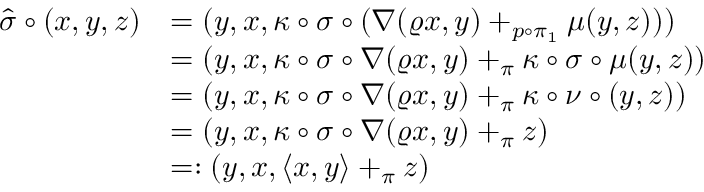<formula> <loc_0><loc_0><loc_500><loc_500>\begin{array} { r l } { \widehat { \sigma } \circ ( x , y , z ) } & { = ( y , x , \kappa \circ \sigma \circ ( \nabla ( \varrho x , y ) + _ { p \circ \pi _ { 1 } } \mu ( y , z ) ) ) } \\ & { = ( y , x , \kappa \circ \sigma \circ \nabla ( \varrho x , y ) + _ { \pi } \kappa \circ \sigma \circ \mu ( y , z ) ) } \\ & { = ( y , x , \kappa \circ \sigma \circ \nabla ( \varrho x , y ) + _ { \pi } \kappa \circ \nu \circ ( y , z ) ) } \\ & { = ( y , x , \kappa \circ \sigma \circ \nabla ( \varrho x , y ) + _ { \pi } z ) } \\ & { = \colon ( y , x , \langle x , y \rangle + _ { \pi } z ) } \end{array}</formula> 